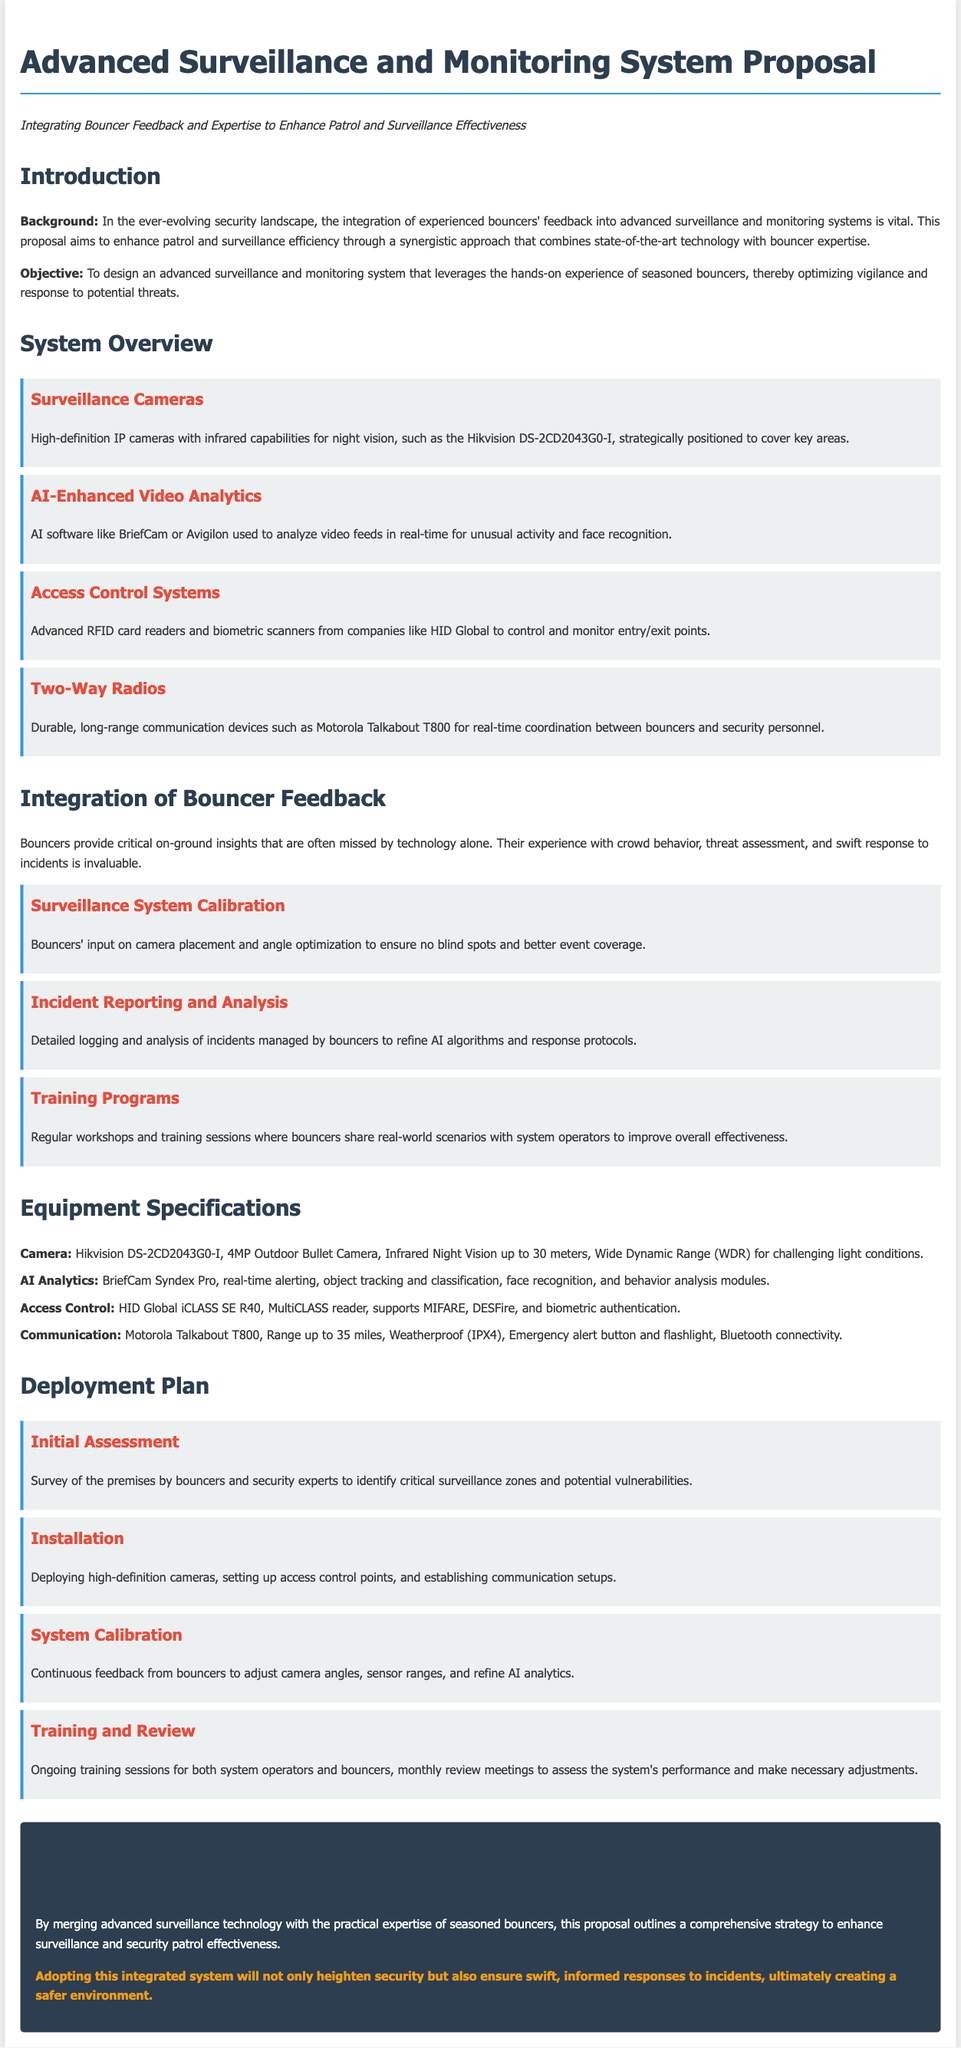What is the title of the proposal? The title of the proposal is the first heading presented in the document.
Answer: Advanced Surveillance and Monitoring System Proposal What is the model of the surveillance camera mentioned? The document specifies a particular model of the surveillance camera in the Equipment Specifications section.
Answer: Hikvision DS-2CD2043G0-I What is the purpose of integrating bouncers' feedback? The purpose is outlined in the objective section of the proposal.
Answer: Optimizing vigilance and response to potential threats How many phases are described in the deployment plan? The number of phases is stated in the Deployment Plan section, listing each step.
Answer: Four Which AI analytics software is mentioned in the proposal? This information can be found in the System Overview section.
Answer: BriefCam What is a key component of the communication system specified? A specific device is listed under the Communication component in the Equipment Specifications section.
Answer: Motorola Talkabout T800 What type of training programs are proposed? The proposal mentions specific activities related to training in the Integration of Bouncer Feedback section.
Answer: Regular workshops What feature do the cameras have that aids in low light conditions? The feature enhancing camera performance under difficult lighting is described in the component details.
Answer: Infrared capabilities 